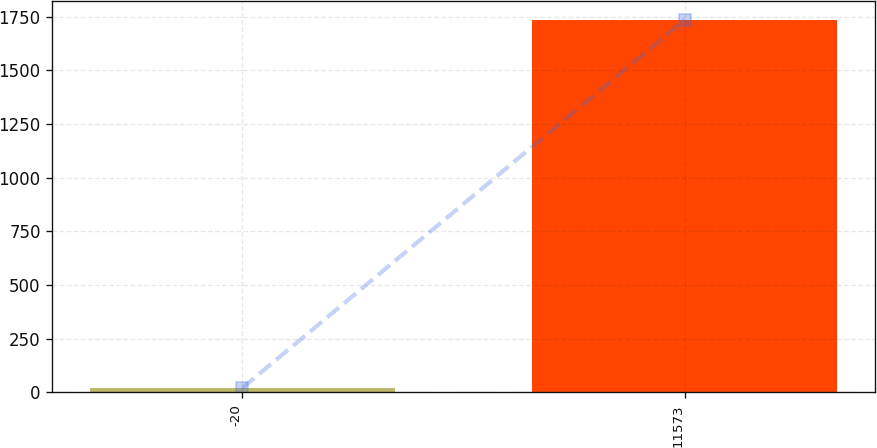Convert chart to OTSL. <chart><loc_0><loc_0><loc_500><loc_500><bar_chart><fcel>-20<fcel>11573<nl><fcel>20<fcel>1736<nl></chart> 